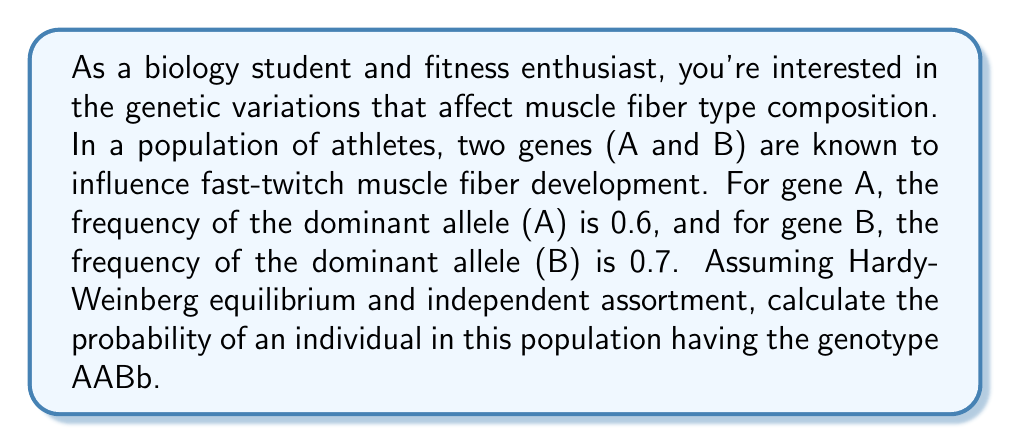Could you help me with this problem? To solve this problem, we'll follow these steps:

1. Calculate the frequencies of all alleles:
   For gene A: $p(A) = 0.6$, $q(a) = 1 - 0.6 = 0.4$
   For gene B: $p(B) = 0.7$, $q(b) = 1 - 0.7 = 0.3$

2. Use the Hardy-Weinberg principle to calculate genotype frequencies:
   For AA: $p^2 = 0.6^2 = 0.36$
   For Bb: $2pq = 2(0.7)(0.3) = 0.42$

3. Since the genes assort independently, multiply the probabilities:

   $P(AABb) = P(AA) \times P(Bb)$

   $P(AABb) = 0.36 \times 0.42$

4. Calculate the final probability:

   $P(AABb) = 0.36 \times 0.42 = 0.1512$

Therefore, the probability of an individual in this population having the genotype AABb is 0.1512 or 15.12%.
Answer: 0.1512 or 15.12% 